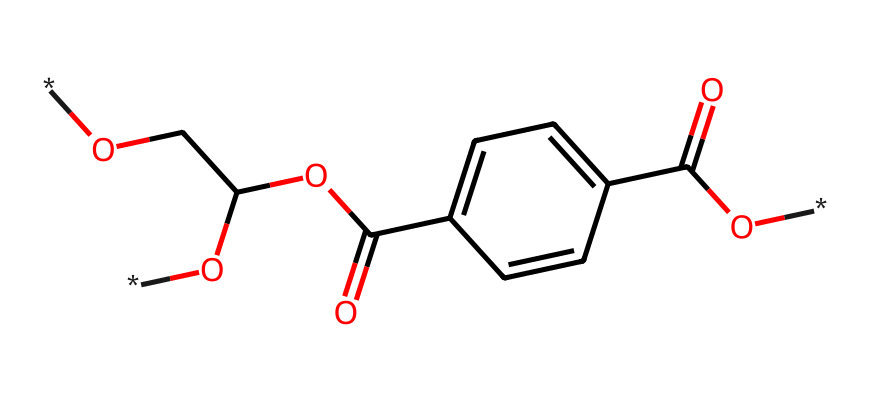How many carbon atoms are in PET? By analyzing the SMILES representation, we can count the number of carbon atoms (C) in the structure. The structure reveals four separate carbon atoms directly connected to other elements and forming the aromatic ring.
Answer: four What functional groups are present in the chemical? Looking at the structure, we can identify functional groups by examining the SMILES notation. The structure displays a carboxylic acid (-COOH) and an ester (RCOOR') which can be noticed by the presence of carbonyl (C=O) and hydroxyl (C-OH) groups.
Answer: carboxylic acid, ester What is the molecular weight of PET? To calculate the molecular weight, we must identify each atom's contribution from the structure. The composition sums up as: C: 10, H: 8, O: 4. Using their atomic weights (C=12.01, H=1.01, O=16.00), we calculate: (10*12.01) + (8*1.01) + (4*16.00) = 192.28 g/mol.
Answer: 192.28 g/mol Does PET contain any nitrogen atoms? Investigating the SMILES representation, we can identify the presence of nitrogen by looking closely at the chemical structure. There are no nitrogen (N) atoms shown in the structure provided.
Answer: no What type of bonding is present in the structure of PET? In PET, we see covalent bonds predominately. The presence of carbon-carbon and carbon-oxygen bonds, along with the functional groups, indicates that the connectivity is predominantly through covalent bonds rather than ionic or metallic.
Answer: covalent Is PET soluble in water? Considering PET's structure as a non-electrolyte with hydrophobic characteristics due to long carbon chains and few polar groups, it shows limited solubility in water compared to polar substances.
Answer: limited solubility 